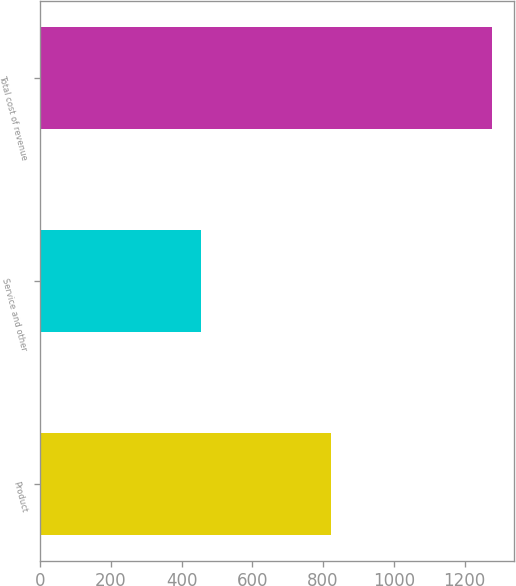<chart> <loc_0><loc_0><loc_500><loc_500><bar_chart><fcel>Product<fcel>Service and other<fcel>Total cost of revenue<nl><fcel>822<fcel>455<fcel>1277<nl></chart> 